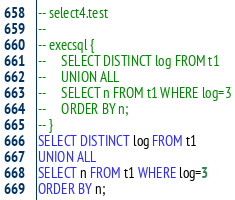Convert code to text. <code><loc_0><loc_0><loc_500><loc_500><_SQL_>-- select4.test
-- 
-- execsql {
--     SELECT DISTINCT log FROM t1
--     UNION ALL
--     SELECT n FROM t1 WHERE log=3
--     ORDER BY n;
-- }
SELECT DISTINCT log FROM t1
UNION ALL
SELECT n FROM t1 WHERE log=3
ORDER BY n;</code> 